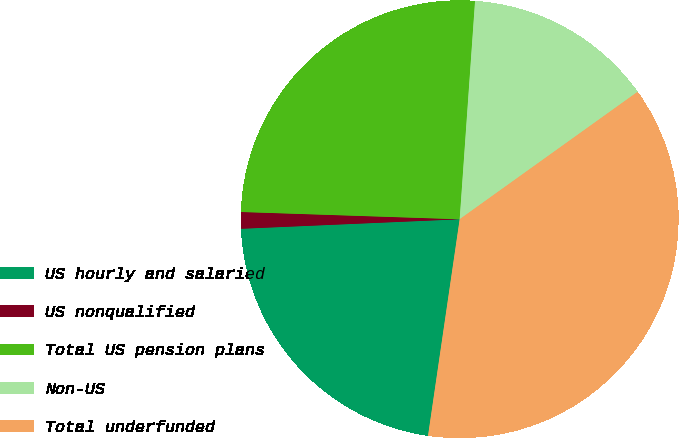<chart> <loc_0><loc_0><loc_500><loc_500><pie_chart><fcel>US hourly and salaried<fcel>US nonqualified<fcel>Total US pension plans<fcel>Non-US<fcel>Total underfunded<nl><fcel>22.0%<fcel>1.22%<fcel>25.59%<fcel>13.99%<fcel>37.2%<nl></chart> 